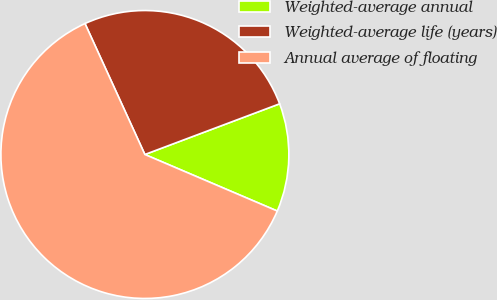Convert chart. <chart><loc_0><loc_0><loc_500><loc_500><pie_chart><fcel>Weighted-average annual<fcel>Weighted-average life (years)<fcel>Annual average of floating<nl><fcel>12.15%<fcel>26.1%<fcel>61.75%<nl></chart> 